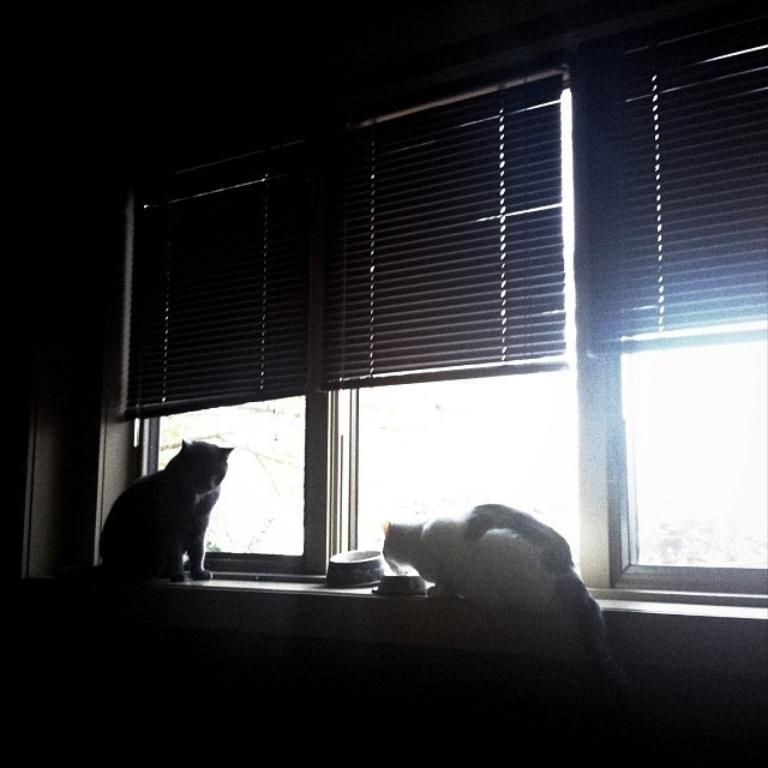How many cats are visible in the image? There are two cats on the desk in the image. What type of window treatment is present in the image? There is a curtain in the image. How many windows can be seen in the image? There are windows in the image. What is the lighting condition in the room? The room appears to be dark. What type of acoustics can be heard in the image? There is no information about the acoustics in the image, as it only features two cats on a desk, a curtain, windows, and a dark room. 